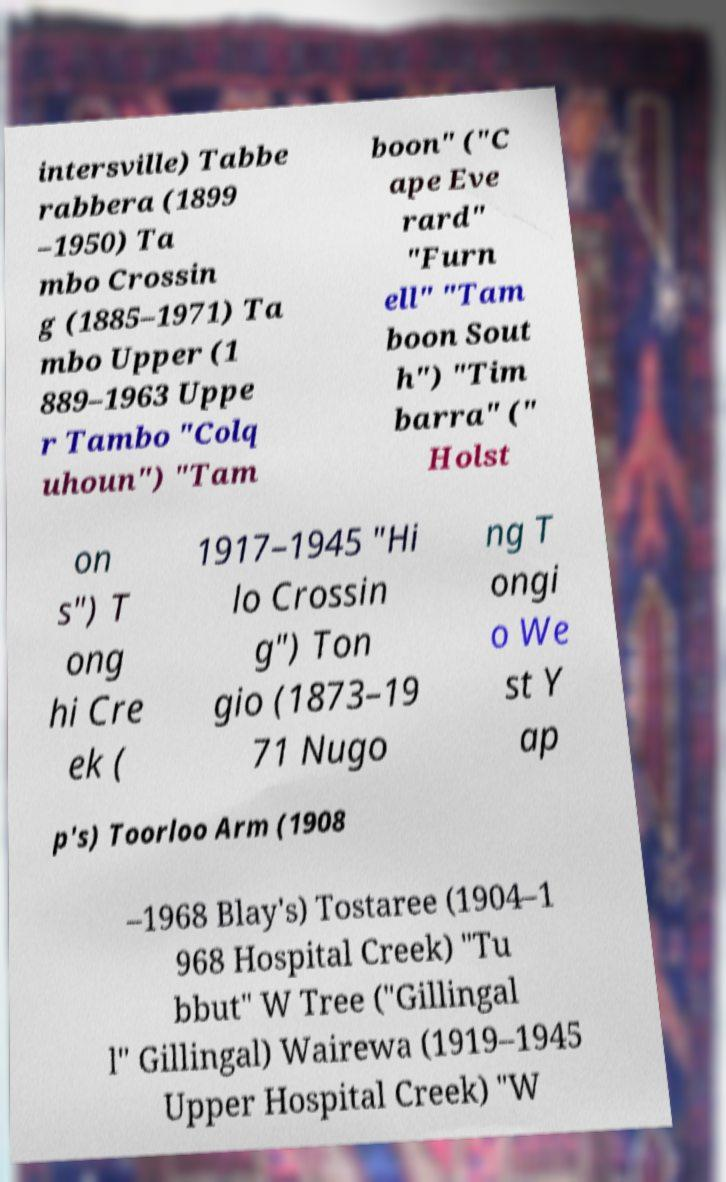Can you read and provide the text displayed in the image?This photo seems to have some interesting text. Can you extract and type it out for me? intersville) Tabbe rabbera (1899 –1950) Ta mbo Crossin g (1885–1971) Ta mbo Upper (1 889–1963 Uppe r Tambo "Colq uhoun") "Tam boon" ("C ape Eve rard" "Furn ell" "Tam boon Sout h") "Tim barra" (" Holst on s") T ong hi Cre ek ( 1917–1945 "Hi lo Crossin g") Ton gio (1873–19 71 Nugo ng T ongi o We st Y ap p's) Toorloo Arm (1908 –1968 Blay's) Tostaree (1904–1 968 Hospital Creek) "Tu bbut" W Tree ("Gillingal l" Gillingal) Wairewa (1919–1945 Upper Hospital Creek) "W 